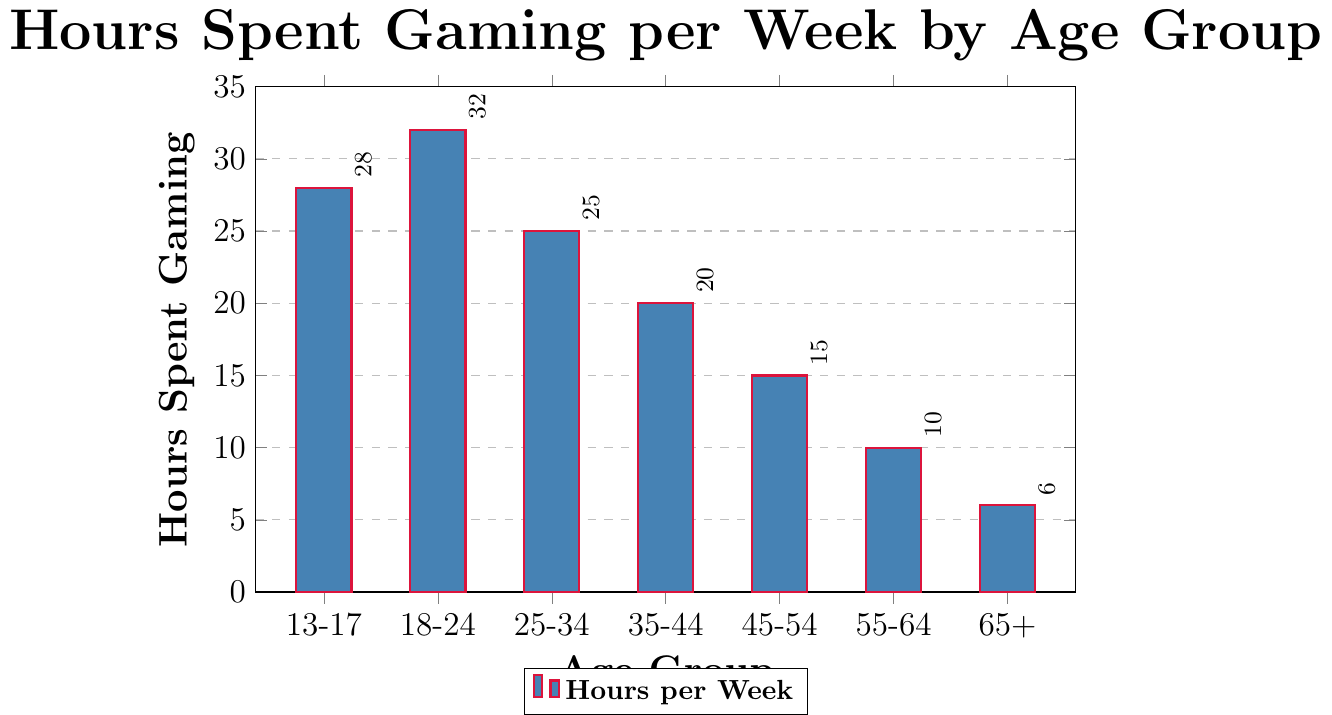Which age group spends the most hours gaming per week? The bar corresponding to the age group 18-24 is the tallest, indicating they spend the most hours gaming per week.
Answer: 18-24 What is the difference in hours spent gaming between the 13-17 and 35-44 age groups? The 13-17 age group spends 28 hours while the 35-44 age group spends 20 hours. The difference is calculated as 28 - 20 = 8 hours.
Answer: 8 How much less time does the 65+ age group spend gaming compared to the 18-24 age group? The 65+ age group spends 6 hours and the 18-24 age group spends 32 hours. The difference is calculated as 32 - 6 = 26 hours.
Answer: 26 Which age group has the smallest number of hours spent gaming, and what is that number? The age group with the smallest bar is 65+, and the number of hours spent gaming is indicated as 6.
Answer: 65+, 6 What is the sum of hours spent gaming for the 25-34 and 55-64 age groups? The 25-34 age group spends 25 hours, and the 55-64 age group spends 10 hours. The sum is calculated as 25 + 10 = 35 hours.
Answer: 35 Compare the hours spent gaming between the 18-24 and 45-54 age groups. The 18-24 age group spends 32 hours, while the 45-54 age group spends 15 hours. 32 is greater than 15.
Answer: 18-24 > 45-54 What is the visual color used to fill the bars on the chart? The bars in the chart are filled with the specified blue color.
Answer: Blue What's the average hours spent gaming across all age groups? Add the hours spent for all groups: 28 + 32 + 25 + 20 + 15 + 10 + 6 = 136 hours. There are 7 age groups. So, 136 / 7 = approximately 19.43 hours.
Answer: 19.43 By how many hours does the median age group outplay the least active age group? Median age group (25-34) spends 25 hours. The least active (65+) spends 6 hours. Difference is 25 - 6 = 19 hours.
Answer: 19 If the total weekly hours for the 18-24 and 45-54 age groups are combined, what fraction of the total gaming hours across all groups do they represent? Combined 18-24 and 45-54: 32 + 15 = 47. Total hours: 136. Fraction: 47/136 = approximately 0.345.
Answer: 0.345 